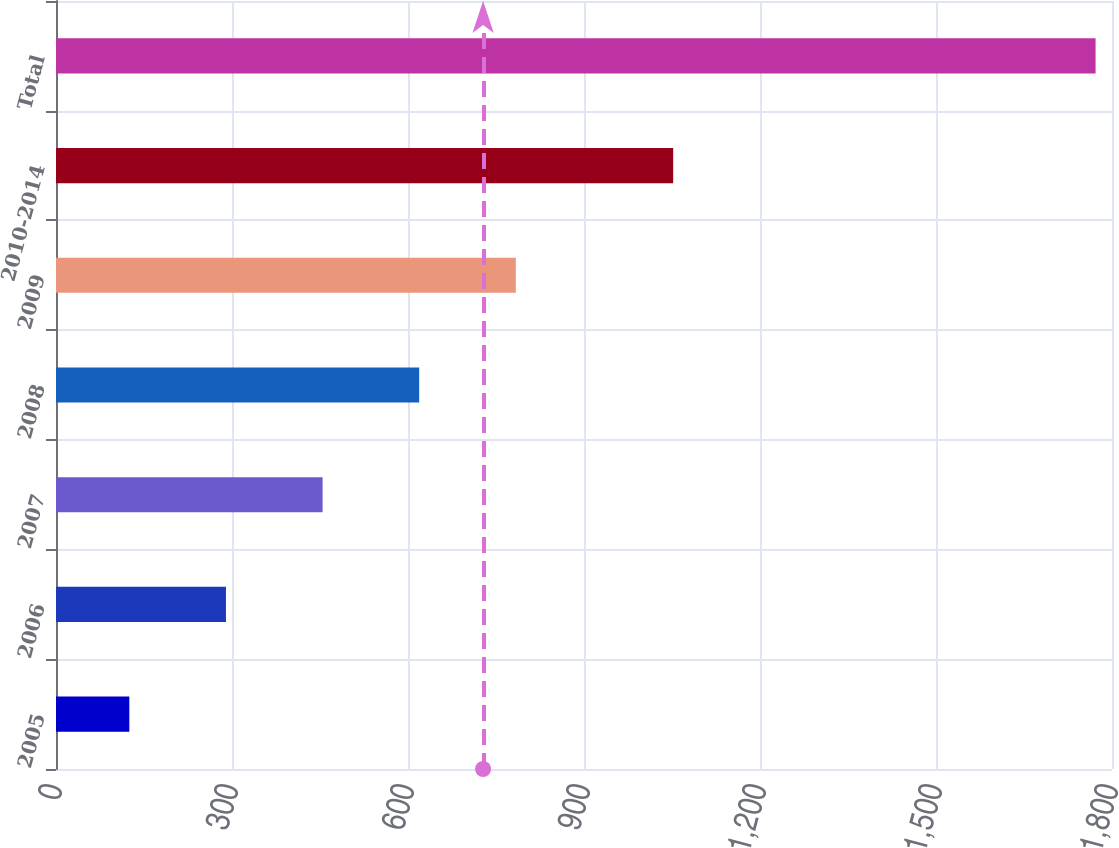Convert chart to OTSL. <chart><loc_0><loc_0><loc_500><loc_500><bar_chart><fcel>2005<fcel>2006<fcel>2007<fcel>2008<fcel>2009<fcel>2010-2014<fcel>Total<nl><fcel>125<fcel>289.7<fcel>454.4<fcel>619.1<fcel>783.8<fcel>1052<fcel>1772<nl></chart> 